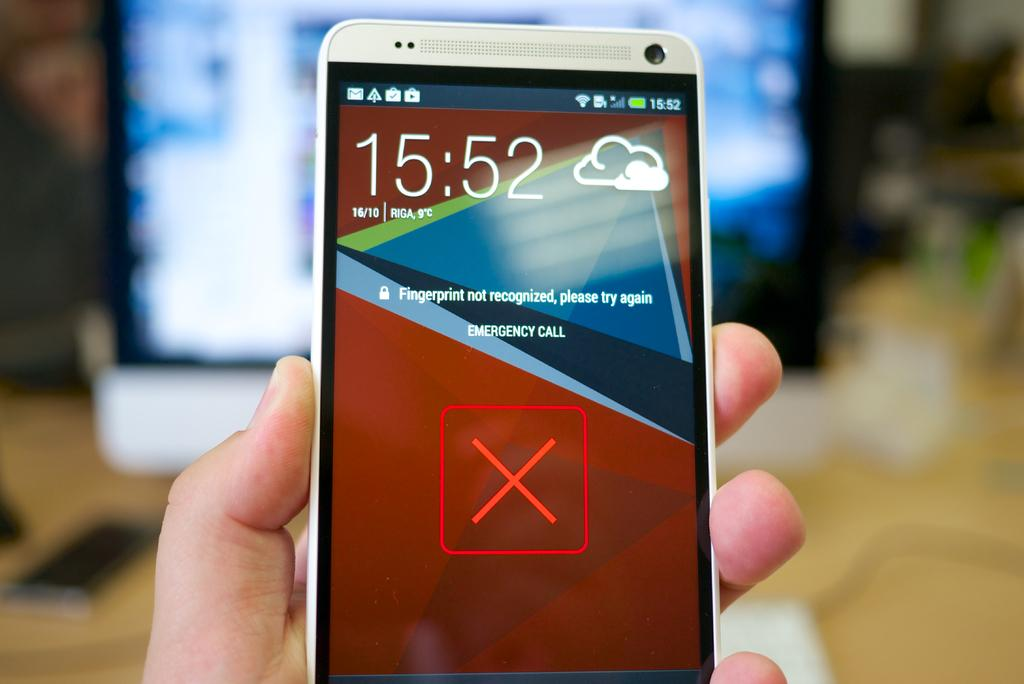<image>
Render a clear and concise summary of the photo. A smart device that shows that the fingerprint was not recognized. 